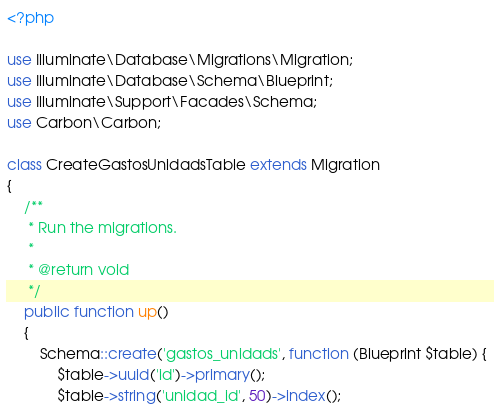<code> <loc_0><loc_0><loc_500><loc_500><_PHP_><?php

use Illuminate\Database\Migrations\Migration;
use Illuminate\Database\Schema\Blueprint;
use Illuminate\Support\Facades\Schema;
use Carbon\Carbon;

class CreateGastosUnidadsTable extends Migration
{
    /**
     * Run the migrations.
     *
     * @return void
     */
    public function up()
    {
        Schema::create('gastos_unidads', function (Blueprint $table) {
            $table->uuid('id')->primary();
            $table->string('unidad_id', 50)->index();</code> 